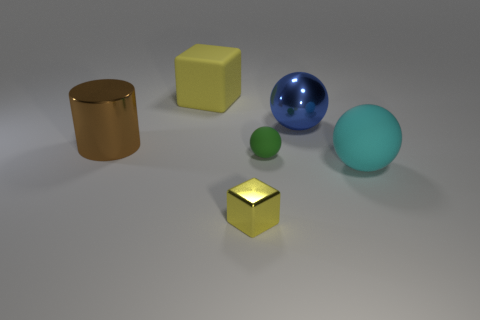Is the number of big cyan things in front of the cyan rubber thing the same as the number of tiny cyan metallic things?
Keep it short and to the point. Yes. Does the cyan ball have the same size as the block behind the cyan rubber ball?
Make the answer very short. Yes. How many other small objects have the same material as the brown object?
Give a very brief answer. 1. Do the green matte object and the rubber block have the same size?
Your answer should be very brief. No. Is there any other thing that is the same color as the metallic block?
Provide a succinct answer. Yes. There is a object that is to the left of the small yellow object and in front of the large yellow block; what is its shape?
Your answer should be very brief. Cylinder. There is a cube that is on the right side of the big yellow matte block; what is its size?
Your answer should be very brief. Small. There is a big shiny thing to the left of the block that is behind the cylinder; what number of big shiny objects are on the right side of it?
Ensure brevity in your answer.  1. Are there any big brown cylinders in front of the yellow rubber thing?
Your answer should be very brief. Yes. What number of other objects are the same size as the green rubber thing?
Keep it short and to the point. 1. 